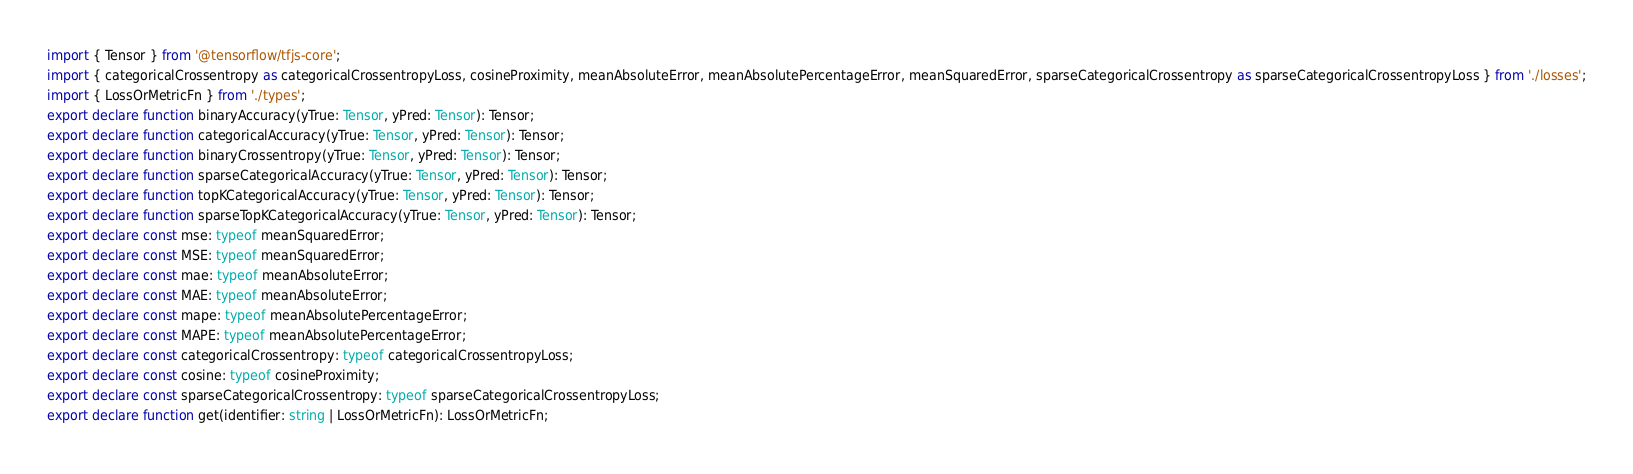Convert code to text. <code><loc_0><loc_0><loc_500><loc_500><_TypeScript_>import { Tensor } from '@tensorflow/tfjs-core';
import { categoricalCrossentropy as categoricalCrossentropyLoss, cosineProximity, meanAbsoluteError, meanAbsolutePercentageError, meanSquaredError, sparseCategoricalCrossentropy as sparseCategoricalCrossentropyLoss } from './losses';
import { LossOrMetricFn } from './types';
export declare function binaryAccuracy(yTrue: Tensor, yPred: Tensor): Tensor;
export declare function categoricalAccuracy(yTrue: Tensor, yPred: Tensor): Tensor;
export declare function binaryCrossentropy(yTrue: Tensor, yPred: Tensor): Tensor;
export declare function sparseCategoricalAccuracy(yTrue: Tensor, yPred: Tensor): Tensor;
export declare function topKCategoricalAccuracy(yTrue: Tensor, yPred: Tensor): Tensor;
export declare function sparseTopKCategoricalAccuracy(yTrue: Tensor, yPred: Tensor): Tensor;
export declare const mse: typeof meanSquaredError;
export declare const MSE: typeof meanSquaredError;
export declare const mae: typeof meanAbsoluteError;
export declare const MAE: typeof meanAbsoluteError;
export declare const mape: typeof meanAbsolutePercentageError;
export declare const MAPE: typeof meanAbsolutePercentageError;
export declare const categoricalCrossentropy: typeof categoricalCrossentropyLoss;
export declare const cosine: typeof cosineProximity;
export declare const sparseCategoricalCrossentropy: typeof sparseCategoricalCrossentropyLoss;
export declare function get(identifier: string | LossOrMetricFn): LossOrMetricFn;
</code> 